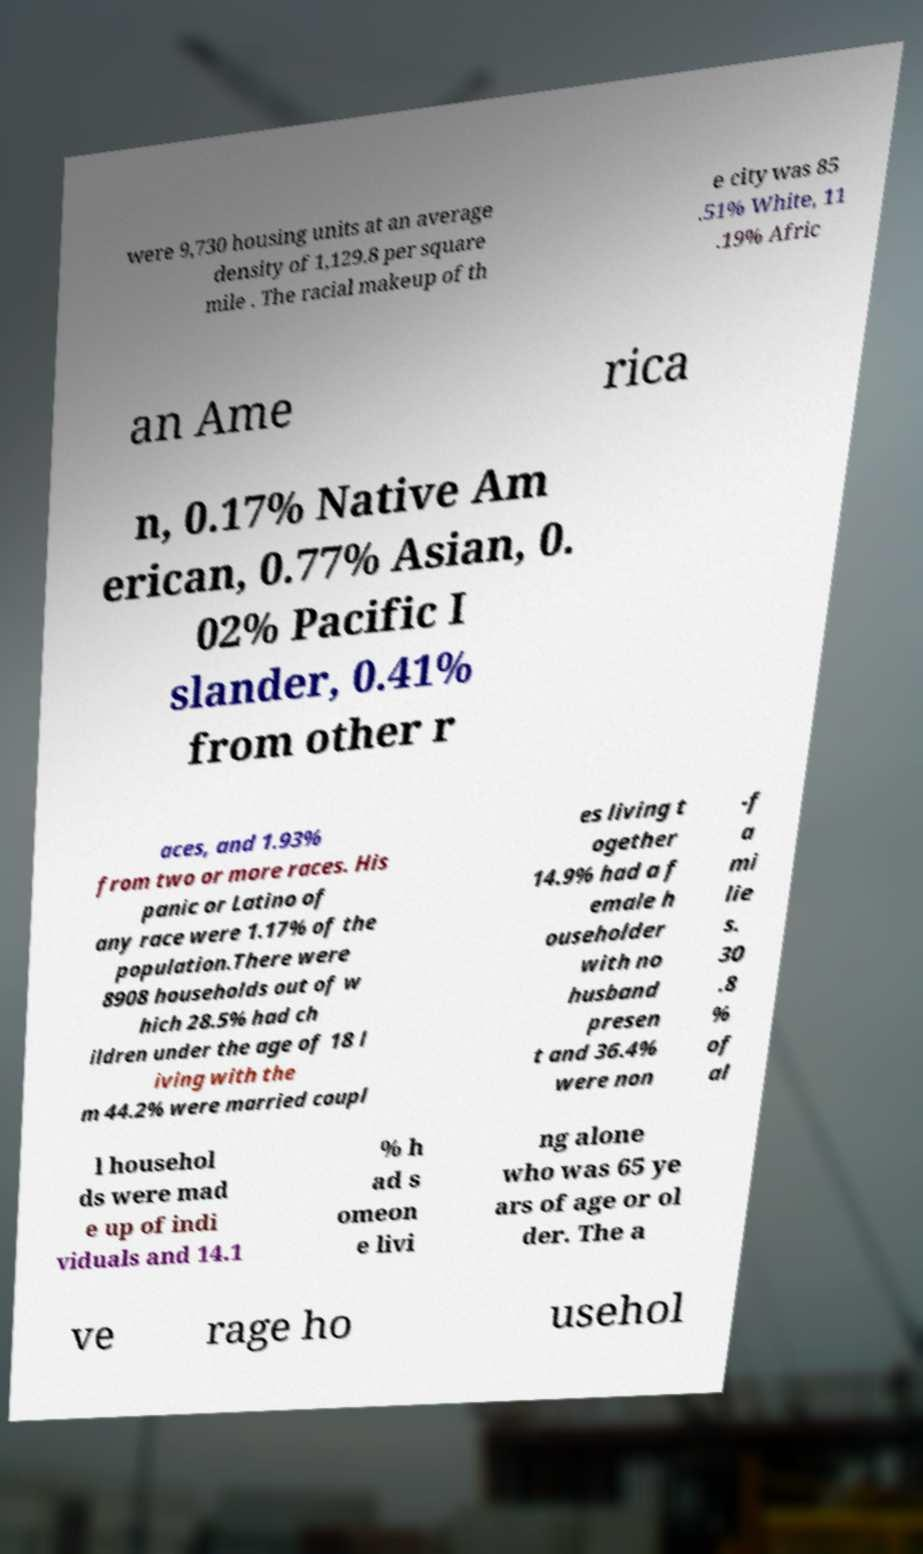For documentation purposes, I need the text within this image transcribed. Could you provide that? were 9,730 housing units at an average density of 1,129.8 per square mile . The racial makeup of th e city was 85 .51% White, 11 .19% Afric an Ame rica n, 0.17% Native Am erican, 0.77% Asian, 0. 02% Pacific I slander, 0.41% from other r aces, and 1.93% from two or more races. His panic or Latino of any race were 1.17% of the population.There were 8908 households out of w hich 28.5% had ch ildren under the age of 18 l iving with the m 44.2% were married coupl es living t ogether 14.9% had a f emale h ouseholder with no husband presen t and 36.4% were non -f a mi lie s. 30 .8 % of al l househol ds were mad e up of indi viduals and 14.1 % h ad s omeon e livi ng alone who was 65 ye ars of age or ol der. The a ve rage ho usehol 